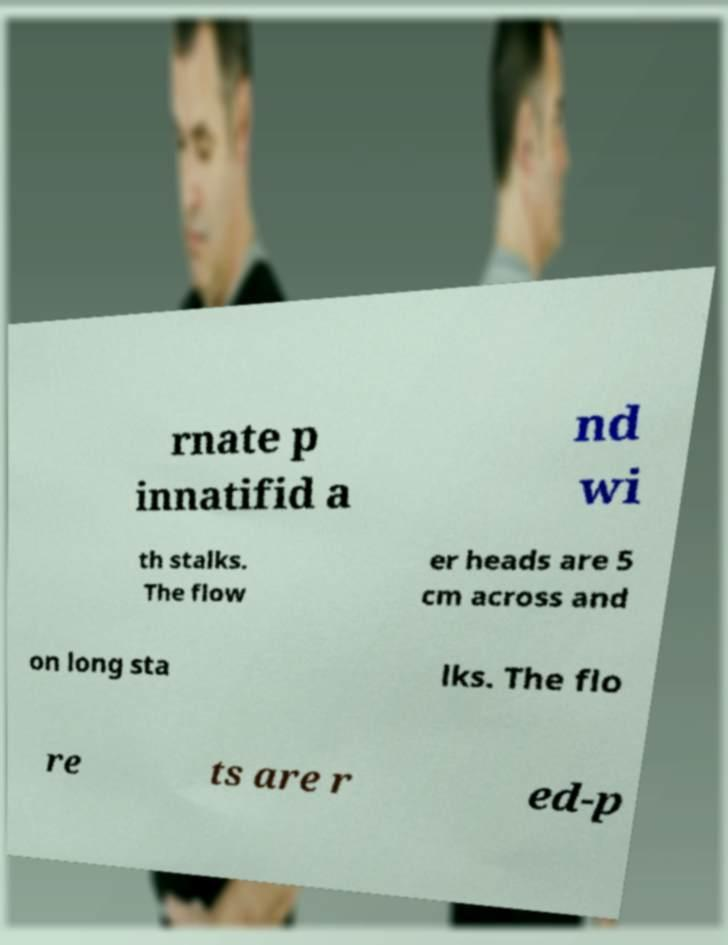Could you extract and type out the text from this image? rnate p innatifid a nd wi th stalks. The flow er heads are 5 cm across and on long sta lks. The flo re ts are r ed-p 